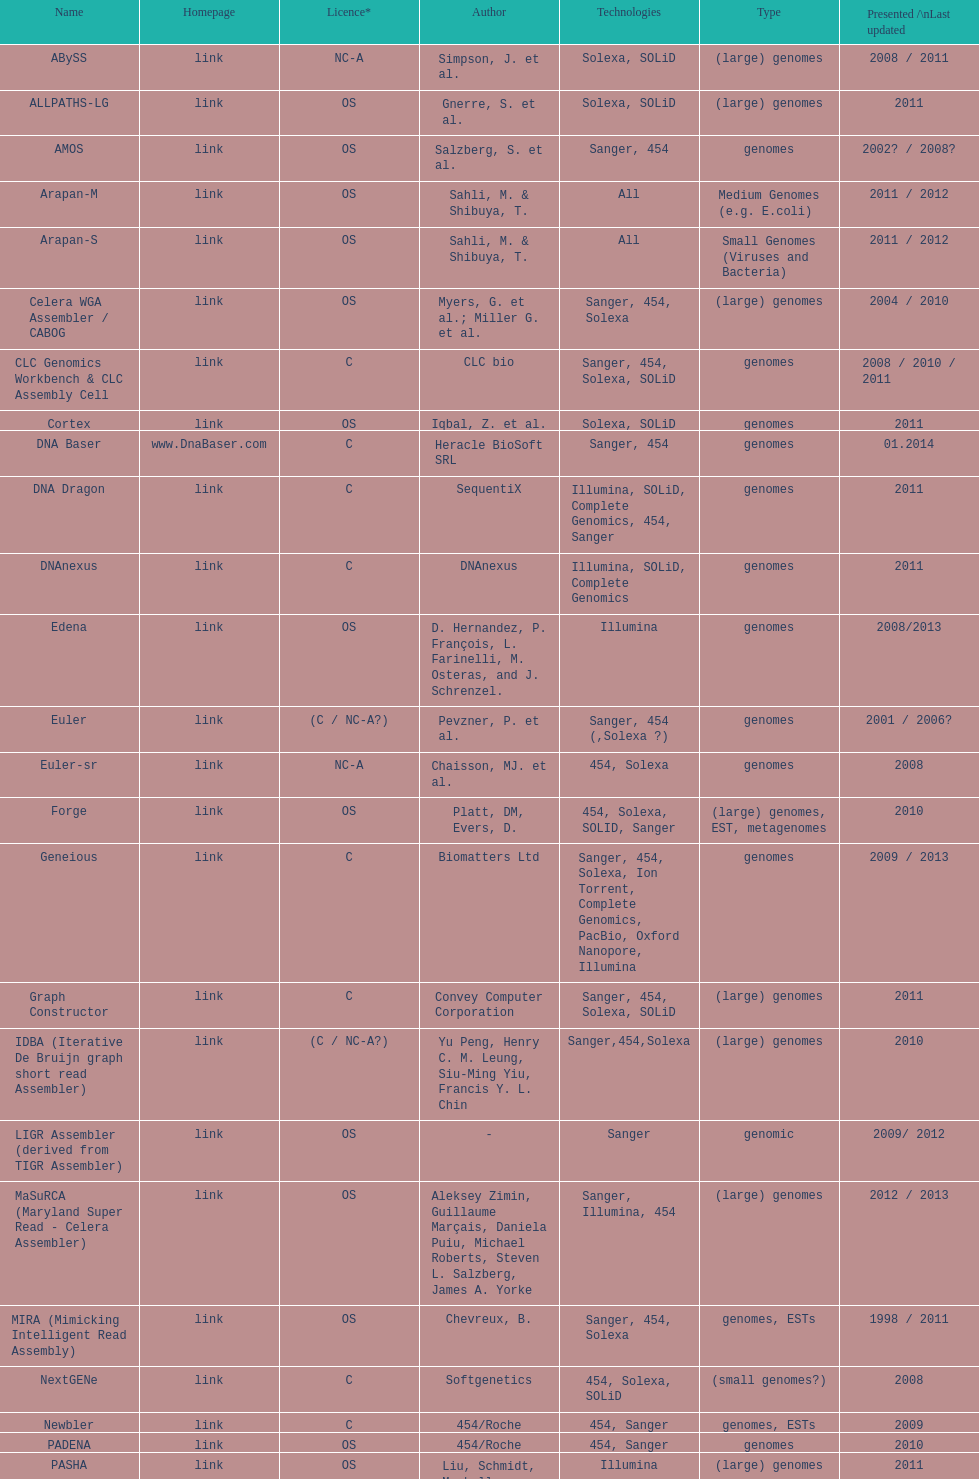Write the full table. {'header': ['Name', 'Homepage', 'Licence*', 'Author', 'Technologies', 'Type', 'Presented /\\nLast updated'], 'rows': [['ABySS', 'link', 'NC-A', 'Simpson, J. et al.', 'Solexa, SOLiD', '(large) genomes', '2008 / 2011'], ['ALLPATHS-LG', 'link', 'OS', 'Gnerre, S. et al.', 'Solexa, SOLiD', '(large) genomes', '2011'], ['AMOS', 'link', 'OS', 'Salzberg, S. et al.', 'Sanger, 454', 'genomes', '2002? / 2008?'], ['Arapan-M', 'link', 'OS', 'Sahli, M. & Shibuya, T.', 'All', 'Medium Genomes (e.g. E.coli)', '2011 / 2012'], ['Arapan-S', 'link', 'OS', 'Sahli, M. & Shibuya, T.', 'All', 'Small Genomes (Viruses and Bacteria)', '2011 / 2012'], ['Celera WGA Assembler / CABOG', 'link', 'OS', 'Myers, G. et al.; Miller G. et al.', 'Sanger, 454, Solexa', '(large) genomes', '2004 / 2010'], ['CLC Genomics Workbench & CLC Assembly Cell', 'link', 'C', 'CLC bio', 'Sanger, 454, Solexa, SOLiD', 'genomes', '2008 / 2010 / 2011'], ['Cortex', 'link', 'OS', 'Iqbal, Z. et al.', 'Solexa, SOLiD', 'genomes', '2011'], ['DNA Baser', 'www.DnaBaser.com', 'C', 'Heracle BioSoft SRL', 'Sanger, 454', 'genomes', '01.2014'], ['DNA Dragon', 'link', 'C', 'SequentiX', 'Illumina, SOLiD, Complete Genomics, 454, Sanger', 'genomes', '2011'], ['DNAnexus', 'link', 'C', 'DNAnexus', 'Illumina, SOLiD, Complete Genomics', 'genomes', '2011'], ['Edena', 'link', 'OS', 'D. Hernandez, P. François, L. Farinelli, M. Osteras, and J. Schrenzel.', 'Illumina', 'genomes', '2008/2013'], ['Euler', 'link', '(C / NC-A?)', 'Pevzner, P. et al.', 'Sanger, 454 (,Solexa\xa0?)', 'genomes', '2001 / 2006?'], ['Euler-sr', 'link', 'NC-A', 'Chaisson, MJ. et al.', '454, Solexa', 'genomes', '2008'], ['Forge', 'link', 'OS', 'Platt, DM, Evers, D.', '454, Solexa, SOLID, Sanger', '(large) genomes, EST, metagenomes', '2010'], ['Geneious', 'link', 'C', 'Biomatters Ltd', 'Sanger, 454, Solexa, Ion Torrent, Complete Genomics, PacBio, Oxford Nanopore, Illumina', 'genomes', '2009 / 2013'], ['Graph Constructor', 'link', 'C', 'Convey Computer Corporation', 'Sanger, 454, Solexa, SOLiD', '(large) genomes', '2011'], ['IDBA (Iterative De Bruijn graph short read Assembler)', 'link', '(C / NC-A?)', 'Yu Peng, Henry C. M. Leung, Siu-Ming Yiu, Francis Y. L. Chin', 'Sanger,454,Solexa', '(large) genomes', '2010'], ['LIGR Assembler (derived from TIGR Assembler)', 'link', 'OS', '-', 'Sanger', 'genomic', '2009/ 2012'], ['MaSuRCA (Maryland Super Read - Celera Assembler)', 'link', 'OS', 'Aleksey Zimin, Guillaume Marçais, Daniela Puiu, Michael Roberts, Steven L. Salzberg, James A. Yorke', 'Sanger, Illumina, 454', '(large) genomes', '2012 / 2013'], ['MIRA (Mimicking Intelligent Read Assembly)', 'link', 'OS', 'Chevreux, B.', 'Sanger, 454, Solexa', 'genomes, ESTs', '1998 / 2011'], ['NextGENe', 'link', 'C', 'Softgenetics', '454, Solexa, SOLiD', '(small genomes?)', '2008'], ['Newbler', 'link', 'C', '454/Roche', '454, Sanger', 'genomes, ESTs', '2009'], ['PADENA', 'link', 'OS', '454/Roche', '454, Sanger', 'genomes', '2010'], ['PASHA', 'link', 'OS', 'Liu, Schmidt, Maskell', 'Illumina', '(large) genomes', '2011'], ['Phrap', 'link', 'C / NC-A', 'Green, P.', 'Sanger, 454, Solexa', 'genomes', '1994 / 2008'], ['TIGR Assembler', 'link', 'OS', '-', 'Sanger', 'genomic', '1995 / 2003'], ['Ray', 'link', 'OS [GNU General Public License]', 'Sébastien Boisvert, François Laviolette & Jacques Corbeil.', 'Illumina, mix of Illumina and 454, paired or not', 'genomes', '2010'], ['Sequencher', 'link', 'C', 'Gene Codes Corporation', 'traditional and next generation sequence data', 'genomes', '1991 / 2009 / 2011'], ['SeqMan NGen', 'link', 'C', 'DNASTAR', 'Illumina, ABI SOLiD, Roche 454, Ion Torrent, Solexa, Sanger', '(large) genomes, exomes, transcriptomes, metagenomes, ESTs', '2007 / 2011'], ['SGA', 'link', 'OS', 'Simpson, J.T. et al.', 'Illumina, Sanger (Roche 454?, Ion Torrent?)', '(large) genomes', '2011 / 2012'], ['SHARCGS', 'link', 'OS', 'Dohm et al.', 'Solexa', '(small) genomes', '2007 / 2007'], ['SOPRA', 'link', 'OS', 'Dayarian, A. et al.', 'Illumina, SOLiD, Sanger, 454', 'genomes', '2010 / 2011'], ['SparseAssembler', 'link', 'OS', 'Ye, C. et al.', 'Illumina, 454, Ion torrent', '(large) genomes', '2012 / 2012'], ['SSAKE', 'link', 'OS', 'Warren, R. et al.', 'Solexa (SOLiD? Helicos?)', '(small) genomes', '2007 / 2007'], ['SOAPdenovo', 'link', 'OS', 'Li, R. et al.', 'Solexa', 'genomes', '2009 / 2009'], ['SPAdes', 'link', 'OS', 'Bankevich, A et al.', 'Illumina, Solexa', '(small) genomes, single-cell', '2012 / 2013'], ['Staden gap4 package', 'link', 'OS', 'Staden et al.', 'Sanger', 'BACs (, small genomes?)', '1991 / 2008'], ['Taipan', 'link', 'OS', 'Schmidt, B. et al.', 'Illumina', '(small) genomes', '2009'], ['VCAKE', 'link', 'OS', 'Jeck, W. et al.', 'Solexa (SOLiD?, Helicos?)', '(small) genomes', '2007 / 2007'], ['Phusion assembler', 'link', 'OS', 'Mullikin JC, et al.', 'Sanger', '(large) genomes', '2003'], ['Quality Value Guided SRA (QSRA)', 'link', 'OS', 'Bryant DW, et al.', 'Sanger, Solexa', 'genomes', '2009'], ['Velvet', 'link', 'OS', 'Zerbino, D. et al.', 'Sanger, 454, Solexa, SOLiD', '(small) genomes', '2007 / 2009']]} What is the total number of technologies classified as "all"? 2. 